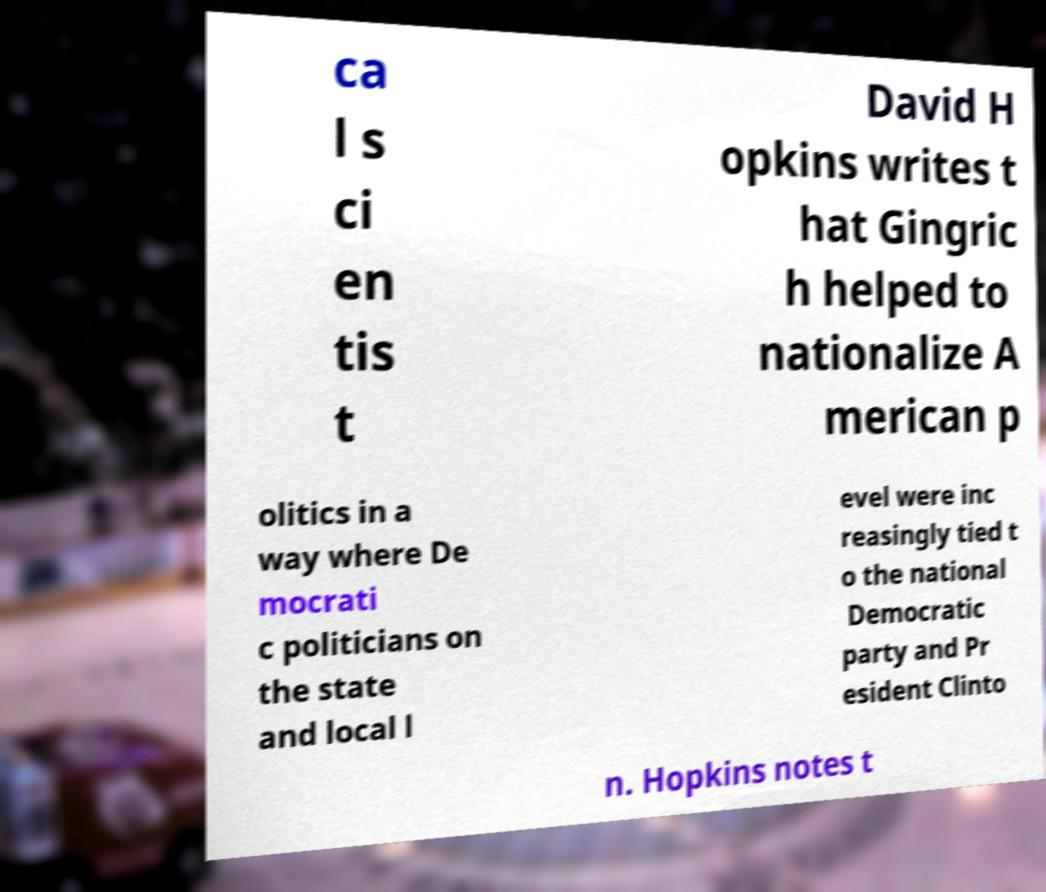Please read and relay the text visible in this image. What does it say? ca l s ci en tis t David H opkins writes t hat Gingric h helped to nationalize A merican p olitics in a way where De mocrati c politicians on the state and local l evel were inc reasingly tied t o the national Democratic party and Pr esident Clinto n. Hopkins notes t 